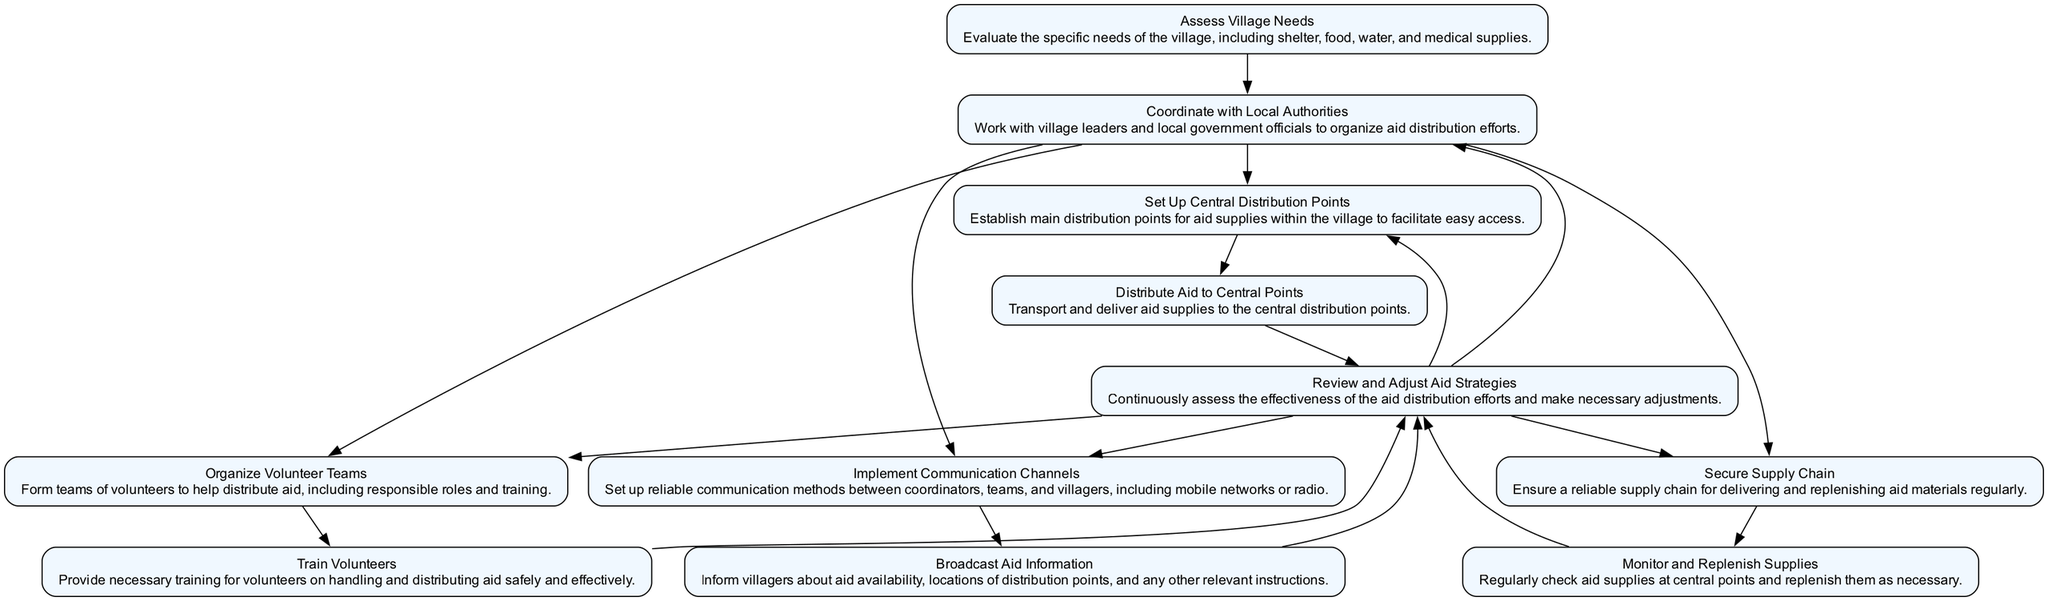What is the first step in the aid distribution process? The first element in the diagram is "Assess Village Needs", which is the initial step that identifies the specific needs of the village post-earthquake.
Answer: Assess Village Needs How many main categories of actions are coordinated after assessing needs? After "Assess Village Needs," there are four subsequent actions that can be taken: "Coordinate with Local Authorities," "Set Up Central Distribution Points," "Organize Volunteer Teams," "Secure Supply Chain," and "Implement Communication Channels," making a total of five actions.
Answer: 5 What follows after setting up central distribution points? After "Set Up Central Distribution Points," the next step indicated in the diagram is "Distribute Aid to Central Points," making it the direct successor in the flow.
Answer: Distribute Aid to Central Points What is the purpose of implementing communication channels? The purpose of "Implement Communication Channels" is to establish reliable methods of communication between coordinators, teams, and villagers, which is crucial for coordination during aid distribution.
Answer: Establish reliable methods Which node must be traversed after securing the supply chain? After "Secure Supply Chain," the flow progresses to "Monitor and Replenish Supplies," indicating a continuous evaluation of the supply chain for delivery effectiveness.
Answer: Monitor and Replenish Supplies How many steps lead to the "Review and Adjust Aid Strategies" node? The "Review and Adjust Aid Strategies" node has multiple incoming steps; specifically, it can be reached from any of the four preceding steps: "Set Up Central Distribution Points," "Organize Volunteer Teams," "Secure Supply Chain," and "Implement Communication Channels," which count up to four steps leading into it.
Answer: 4 When should the volunteers be trained in relation to the distribution process? Volunteers should be trained after "Organize Volunteer Teams," so the training occurs right before they participate in aid distribution, ensuring they are prepared and knowledgeable.
Answer: After Organize Volunteer Teams What needs to be monitored regularly according to the flowchart? The step labeled "Monitor and Replenish Supplies" explicitly states that regular checks on aid supplies at central points are necessary to ensure that they meet the demands of the village.
Answer: Aid supplies Which step requires collaboration with village leaders and local authorities? The step "Coordinate with Local Authorities" necessitates collaboration with village leaders and local government officials to organize the distribution of aid effectively.
Answer: Coordinate with Local Authorities 